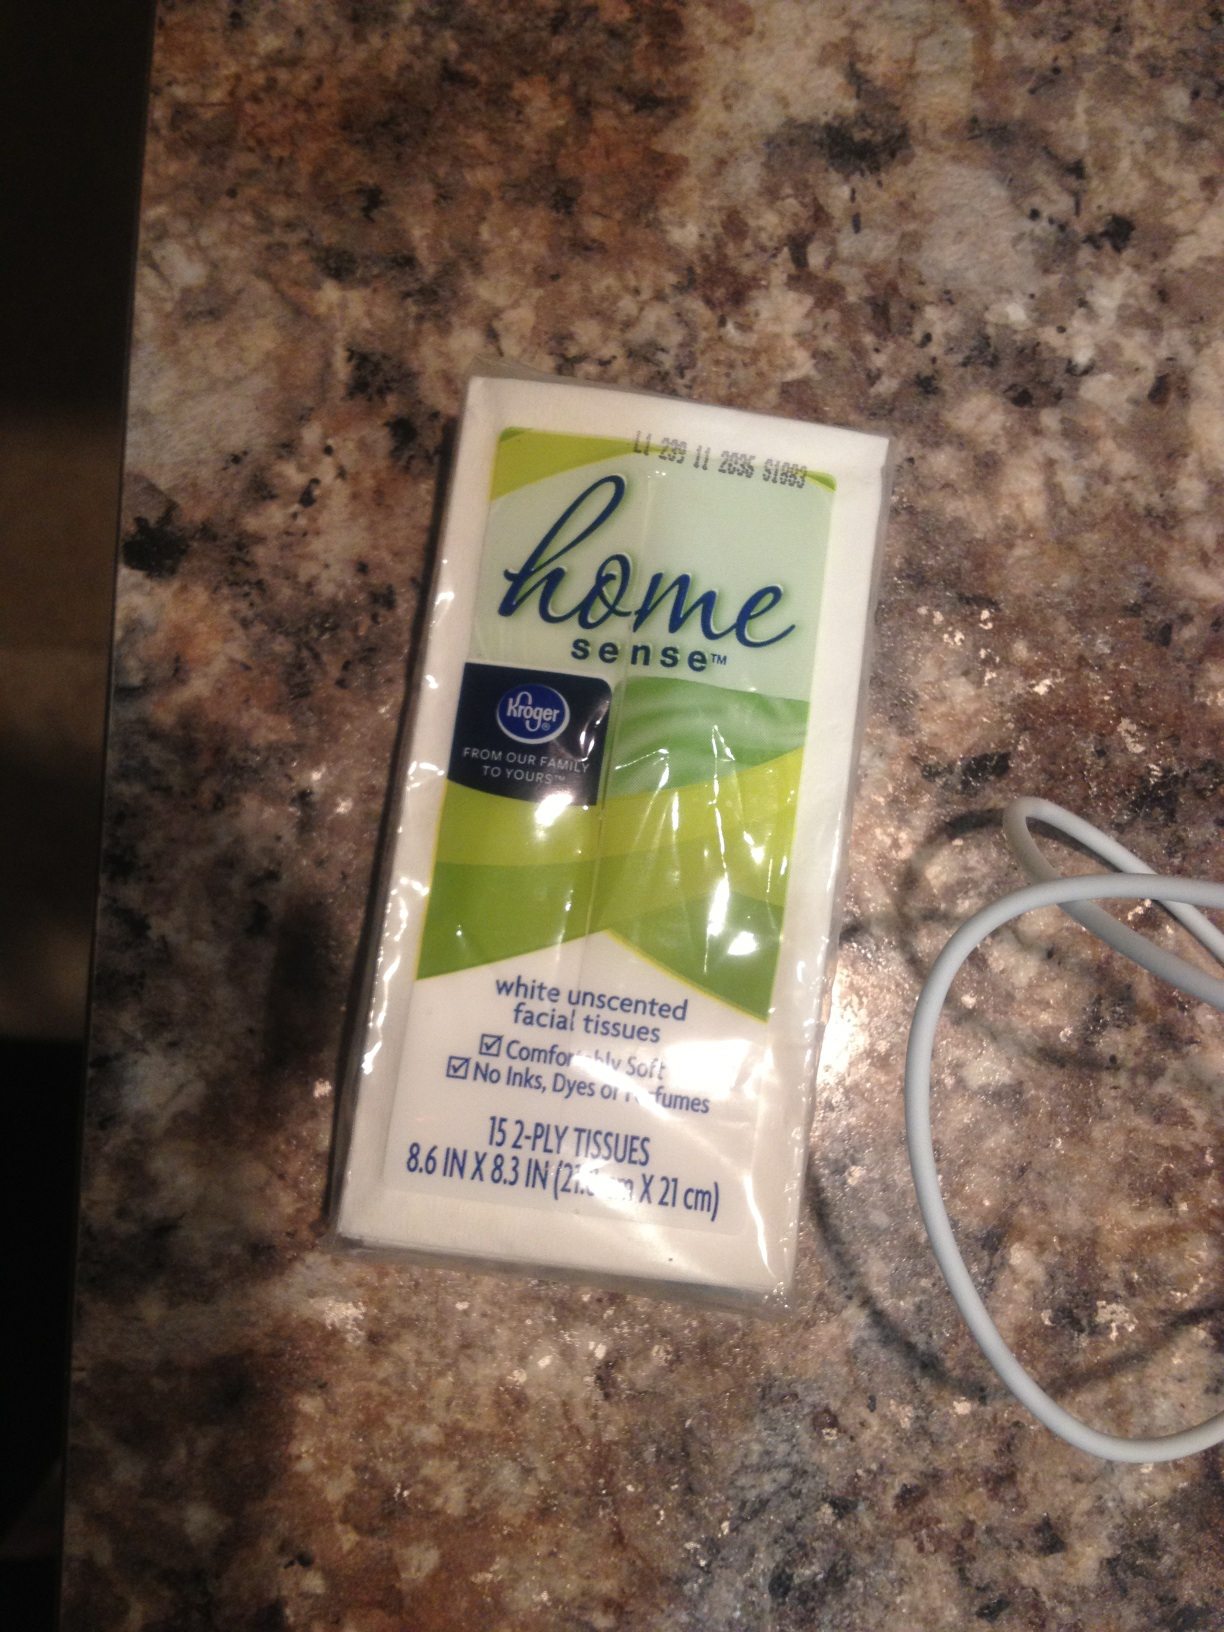Hey can you tell me how much this weighs? Thanks. The image shows a pack of Home Sense white unscented facial tissues containing 15 2-ply tissues. Generally, such a small packet of facial tissues weighs around 20 to 30 grams. For an exact weight, you might need to refer to the packaging details or a scale. 